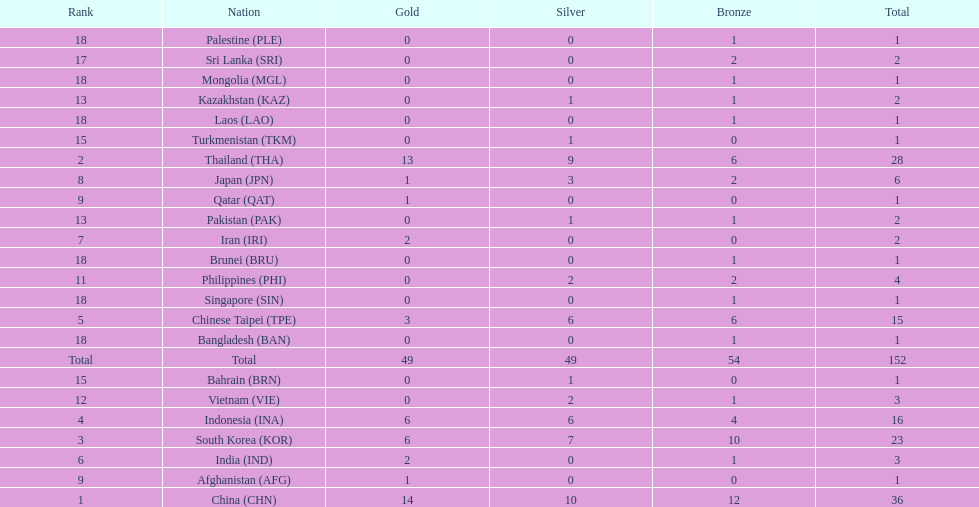How many total gold medal have been given? 49. 